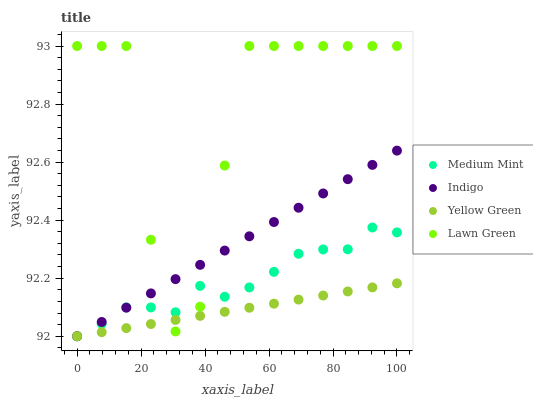Does Yellow Green have the minimum area under the curve?
Answer yes or no. Yes. Does Lawn Green have the maximum area under the curve?
Answer yes or no. Yes. Does Indigo have the minimum area under the curve?
Answer yes or no. No. Does Indigo have the maximum area under the curve?
Answer yes or no. No. Is Yellow Green the smoothest?
Answer yes or no. Yes. Is Lawn Green the roughest?
Answer yes or no. Yes. Is Indigo the smoothest?
Answer yes or no. No. Is Indigo the roughest?
Answer yes or no. No. Does Medium Mint have the lowest value?
Answer yes or no. Yes. Does Lawn Green have the lowest value?
Answer yes or no. No. Does Lawn Green have the highest value?
Answer yes or no. Yes. Does Indigo have the highest value?
Answer yes or no. No. Does Medium Mint intersect Yellow Green?
Answer yes or no. Yes. Is Medium Mint less than Yellow Green?
Answer yes or no. No. Is Medium Mint greater than Yellow Green?
Answer yes or no. No. 